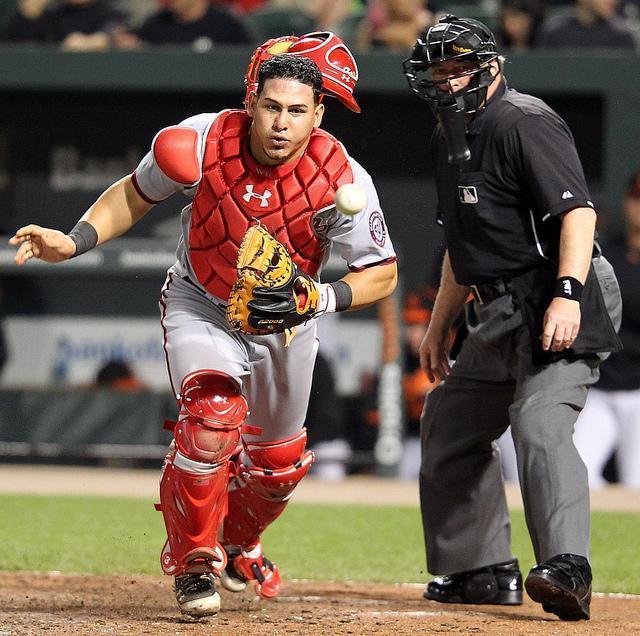How many people are there?
Give a very brief answer. 8. 